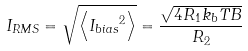<formula> <loc_0><loc_0><loc_500><loc_500>I _ { R M S } = \sqrt { \left \langle { I _ { b i a s } } ^ { 2 } \right \rangle } = \frac { \sqrt { 4 R _ { 1 } k _ { b } T B } } { R _ { 2 } }</formula> 